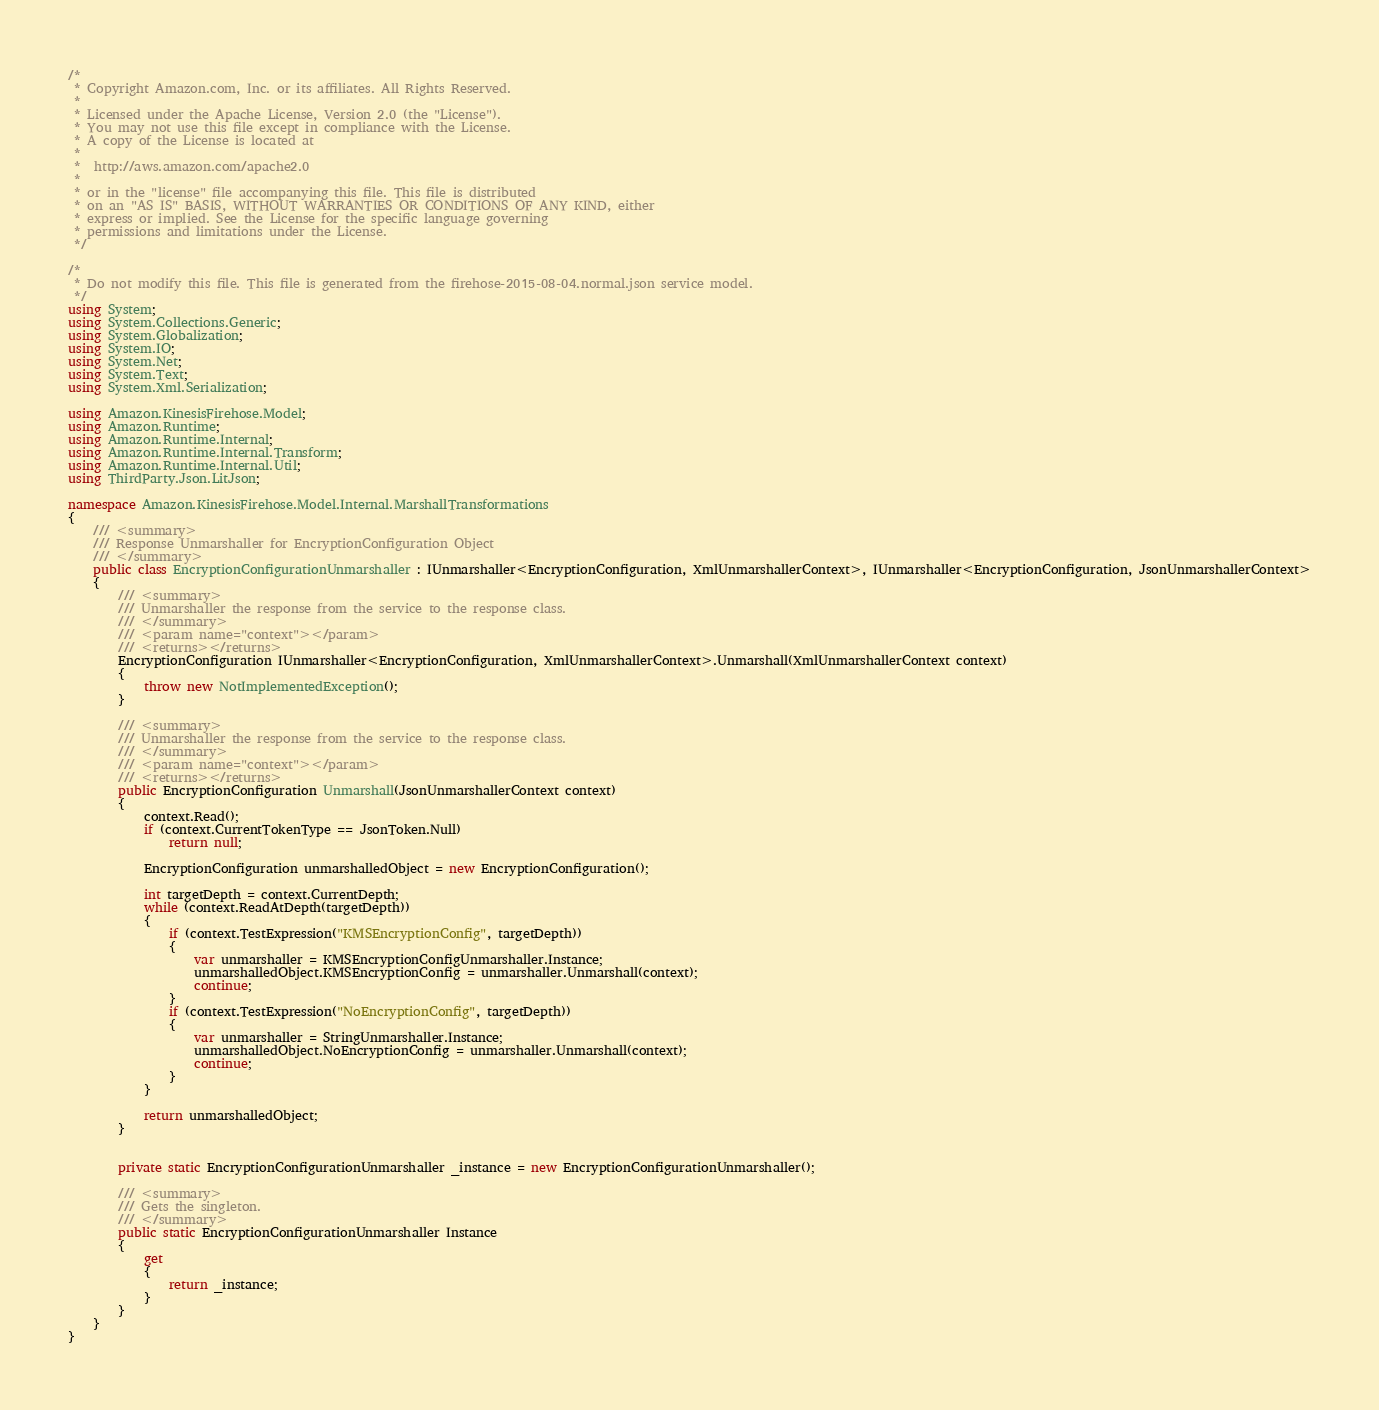Convert code to text. <code><loc_0><loc_0><loc_500><loc_500><_C#_>/*
 * Copyright Amazon.com, Inc. or its affiliates. All Rights Reserved.
 * 
 * Licensed under the Apache License, Version 2.0 (the "License").
 * You may not use this file except in compliance with the License.
 * A copy of the License is located at
 * 
 *  http://aws.amazon.com/apache2.0
 * 
 * or in the "license" file accompanying this file. This file is distributed
 * on an "AS IS" BASIS, WITHOUT WARRANTIES OR CONDITIONS OF ANY KIND, either
 * express or implied. See the License for the specific language governing
 * permissions and limitations under the License.
 */

/*
 * Do not modify this file. This file is generated from the firehose-2015-08-04.normal.json service model.
 */
using System;
using System.Collections.Generic;
using System.Globalization;
using System.IO;
using System.Net;
using System.Text;
using System.Xml.Serialization;

using Amazon.KinesisFirehose.Model;
using Amazon.Runtime;
using Amazon.Runtime.Internal;
using Amazon.Runtime.Internal.Transform;
using Amazon.Runtime.Internal.Util;
using ThirdParty.Json.LitJson;

namespace Amazon.KinesisFirehose.Model.Internal.MarshallTransformations
{
    /// <summary>
    /// Response Unmarshaller for EncryptionConfiguration Object
    /// </summary>  
    public class EncryptionConfigurationUnmarshaller : IUnmarshaller<EncryptionConfiguration, XmlUnmarshallerContext>, IUnmarshaller<EncryptionConfiguration, JsonUnmarshallerContext>
    {
        /// <summary>
        /// Unmarshaller the response from the service to the response class.
        /// </summary>  
        /// <param name="context"></param>
        /// <returns></returns>
        EncryptionConfiguration IUnmarshaller<EncryptionConfiguration, XmlUnmarshallerContext>.Unmarshall(XmlUnmarshallerContext context)
        {
            throw new NotImplementedException();
        }

        /// <summary>
        /// Unmarshaller the response from the service to the response class.
        /// </summary>  
        /// <param name="context"></param>
        /// <returns></returns>
        public EncryptionConfiguration Unmarshall(JsonUnmarshallerContext context)
        {
            context.Read();
            if (context.CurrentTokenType == JsonToken.Null) 
                return null;

            EncryptionConfiguration unmarshalledObject = new EncryptionConfiguration();
        
            int targetDepth = context.CurrentDepth;
            while (context.ReadAtDepth(targetDepth))
            {
                if (context.TestExpression("KMSEncryptionConfig", targetDepth))
                {
                    var unmarshaller = KMSEncryptionConfigUnmarshaller.Instance;
                    unmarshalledObject.KMSEncryptionConfig = unmarshaller.Unmarshall(context);
                    continue;
                }
                if (context.TestExpression("NoEncryptionConfig", targetDepth))
                {
                    var unmarshaller = StringUnmarshaller.Instance;
                    unmarshalledObject.NoEncryptionConfig = unmarshaller.Unmarshall(context);
                    continue;
                }
            }
          
            return unmarshalledObject;
        }


        private static EncryptionConfigurationUnmarshaller _instance = new EncryptionConfigurationUnmarshaller();        

        /// <summary>
        /// Gets the singleton.
        /// </summary>  
        public static EncryptionConfigurationUnmarshaller Instance
        {
            get
            {
                return _instance;
            }
        }
    }
}</code> 